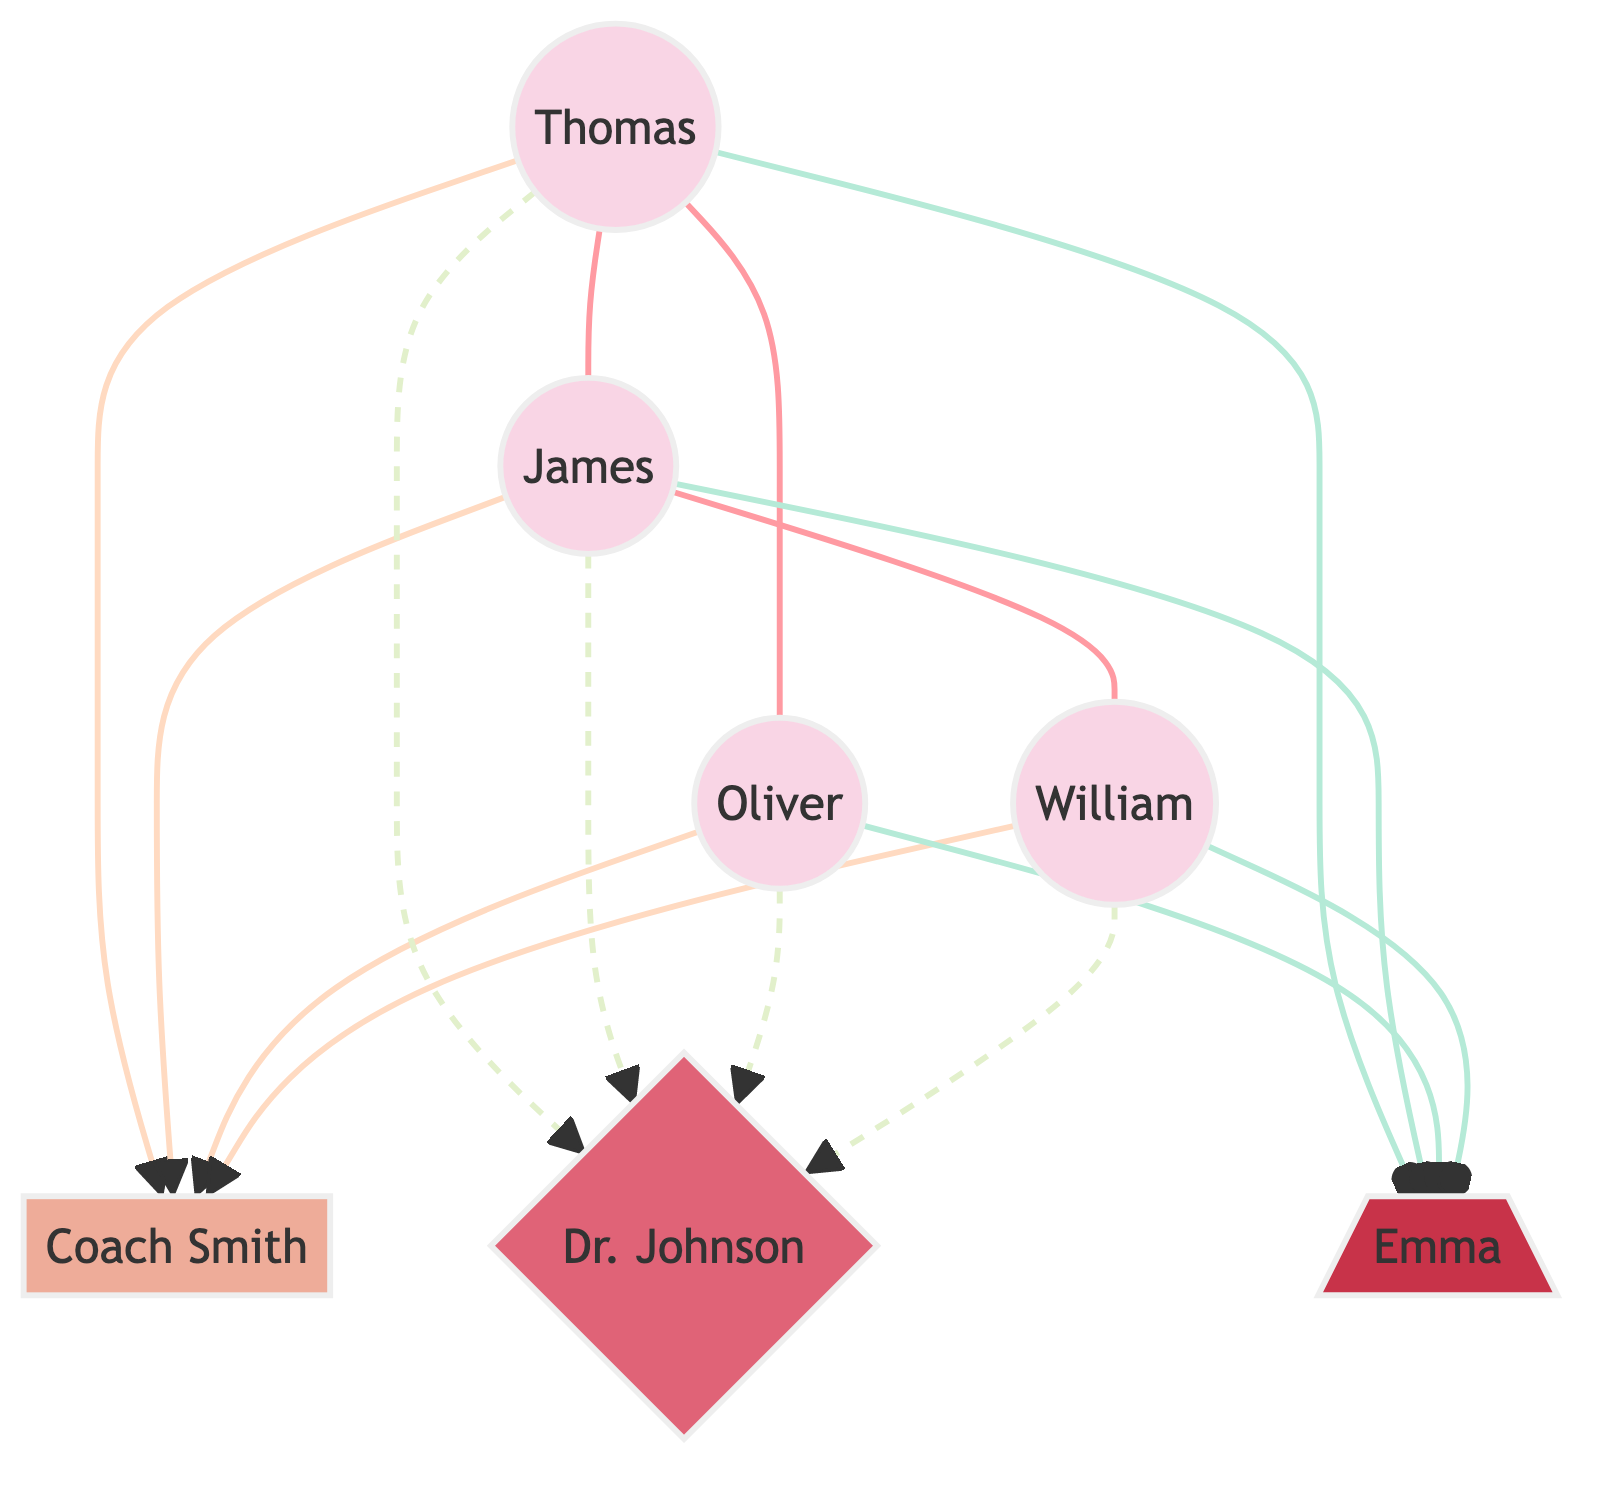What's the total number of athletes in the diagram? There are four athletes represented by the nodes Thomas, James, Oliver, and William. Therefore, counting these nodes gives us a total of four athletes.
Answer: 4 What type of relationship does Thomas have with James? In the diagram, the link between Thomas and James is labeled as "Training Partner," which indicates the nature of their relationship.
Answer: Training Partner Who is the nutritionist for the athletes? The diagram connects all athletes to the node labeled Emma, indicating she is the nutritionist for all the athletes represented.
Answer: Emma How many coaches are depicted in the diagram? The diagram shows only one coach, labeled Coach Smith, who has connections with each athlete. Counting this node confirms there is only one coach.
Answer: 1 Which athlete has the most training partners? Thomas has two training partners: James and Oliver. When comparing him with others, William has the least with only James. The other athletes have one or two as well, making Thomas the athlete with the most.
Answer: Thomas What role does Dr. Johnson play in the athletes' training? Dr. Johnson is linked to all athletes through the relationship labeled "Rehabilitation," indicating his role as their physiotherapist focused on rehabilitation processes.
Answer: Physiotherapist How many rehabilitation links are illustrated in the diagram? Each of the four athletes is connected to Dr. Johnson with a "Rehabilitation" link. Since there are four athletes, this results in a total of four rehabilitation links in the diagram.
Answer: 4 Which athlete has a connection to Coach Smith? All athletes (Thomas, James, Oliver, William) are linked to Coach Smith with the relationship labeled "Coached By," indicating their connection to him as their coach.
Answer: Thomas, James, Oliver, William What is the nature of the relationship between athletes and the nutritionist? Each athlete has a link to the nutritionist labeled "Nutrition Plan," suggesting that all athletes are connected to her for individualized nutrition planning.
Answer: Nutrition Plan 